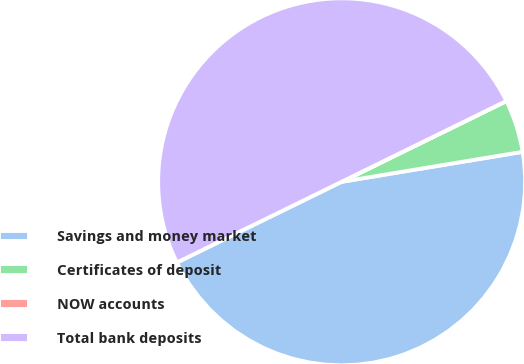<chart> <loc_0><loc_0><loc_500><loc_500><pie_chart><fcel>Savings and money market<fcel>Certificates of deposit<fcel>NOW accounts<fcel>Total bank deposits<nl><fcel>45.36%<fcel>4.64%<fcel>0.01%<fcel>49.99%<nl></chart> 